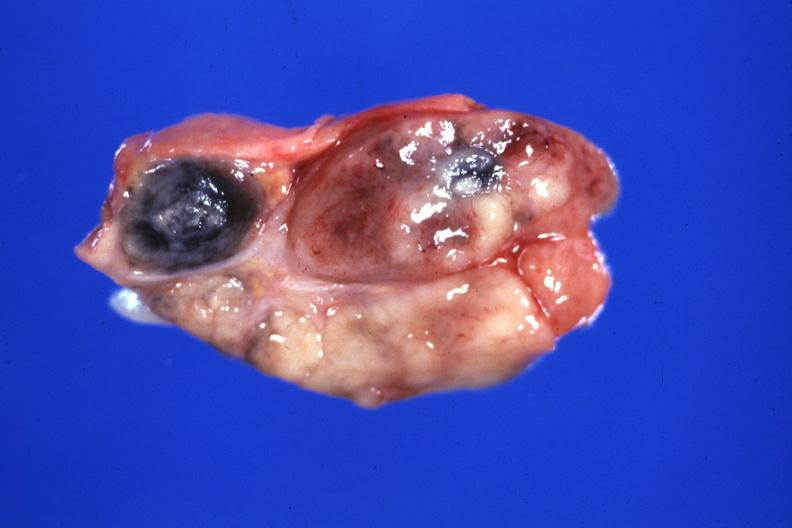s section of spleen through hilum present?
Answer the question using a single word or phrase. No 